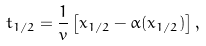Convert formula to latex. <formula><loc_0><loc_0><loc_500><loc_500>t _ { 1 / 2 } = \frac { 1 } { v } \left [ x _ { 1 / 2 } - \alpha ( x _ { 1 / 2 } ) \right ] ,</formula> 